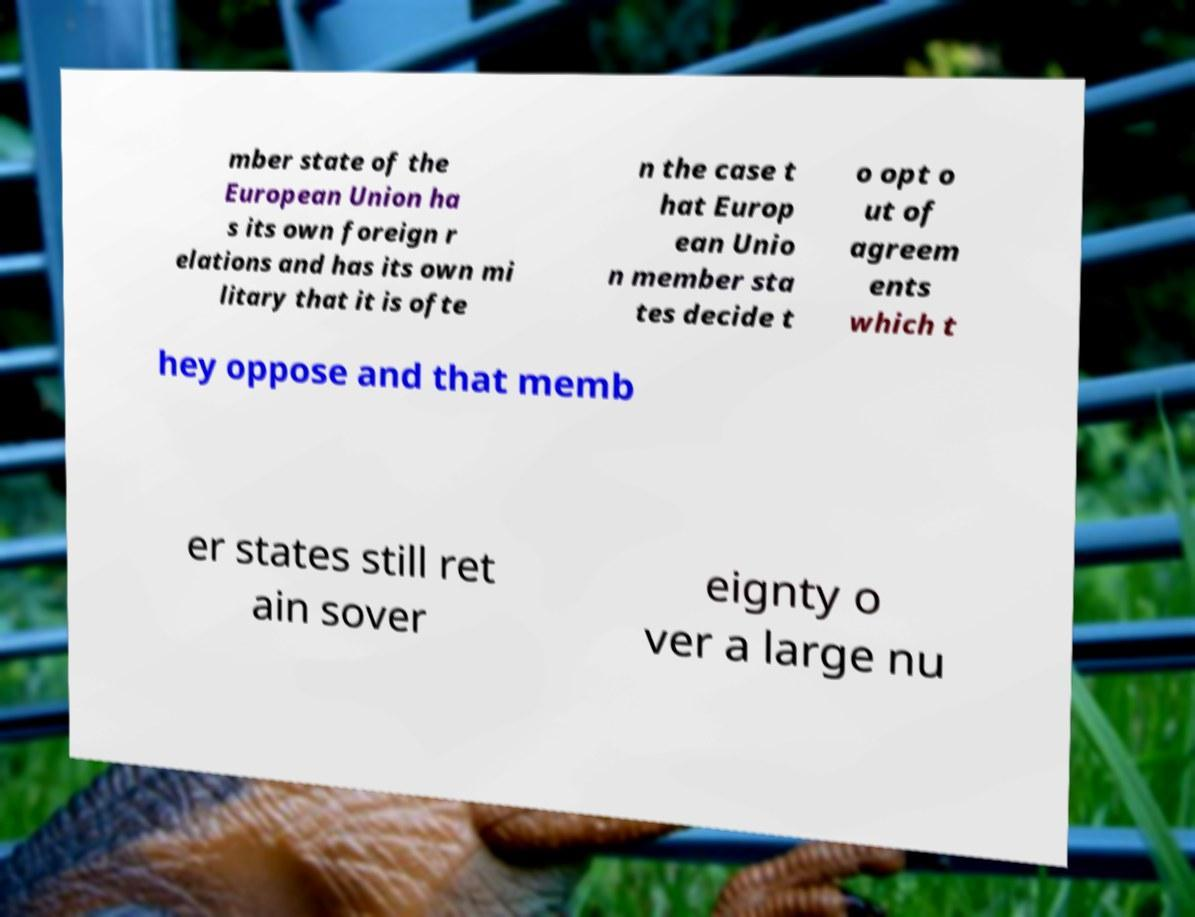Can you accurately transcribe the text from the provided image for me? mber state of the European Union ha s its own foreign r elations and has its own mi litary that it is ofte n the case t hat Europ ean Unio n member sta tes decide t o opt o ut of agreem ents which t hey oppose and that memb er states still ret ain sover eignty o ver a large nu 